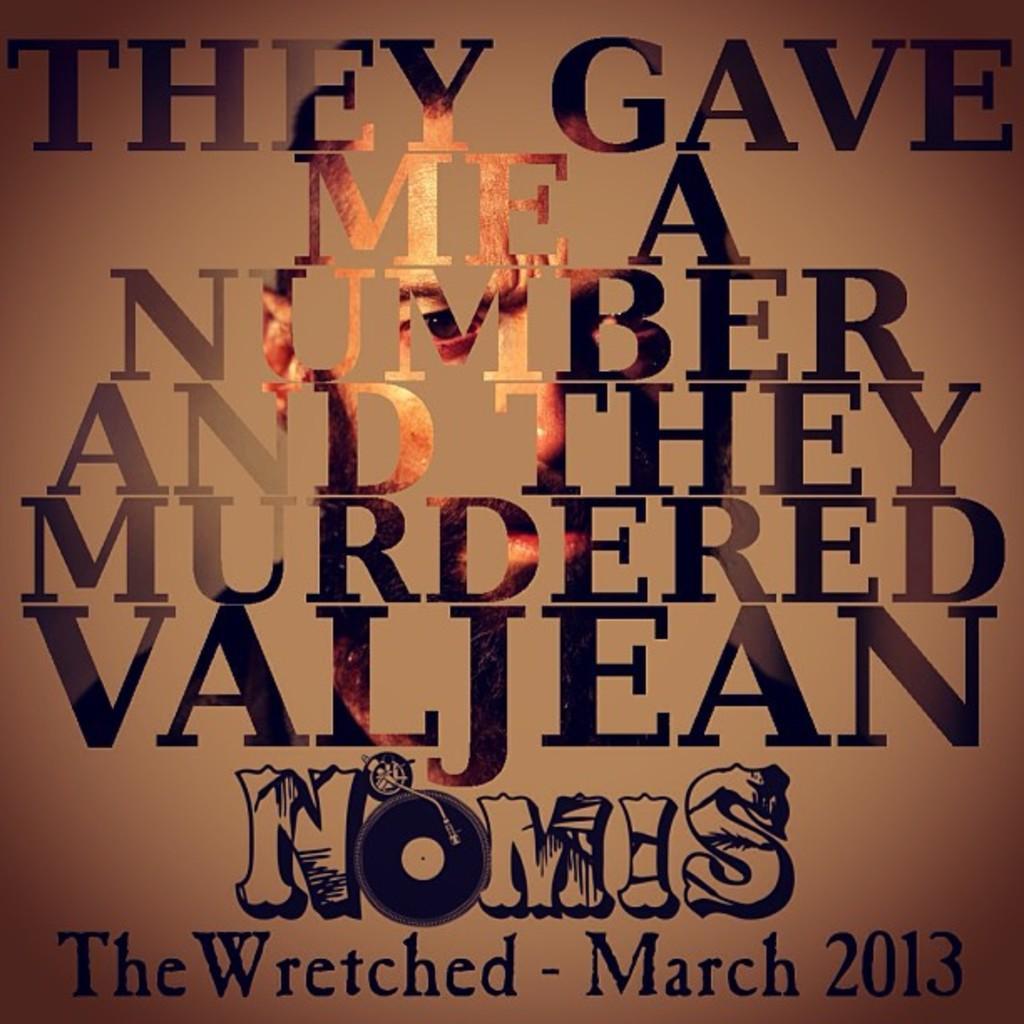Describe this image in one or two sentences. In this picture I can see a board, on which I can see some text and person face. 